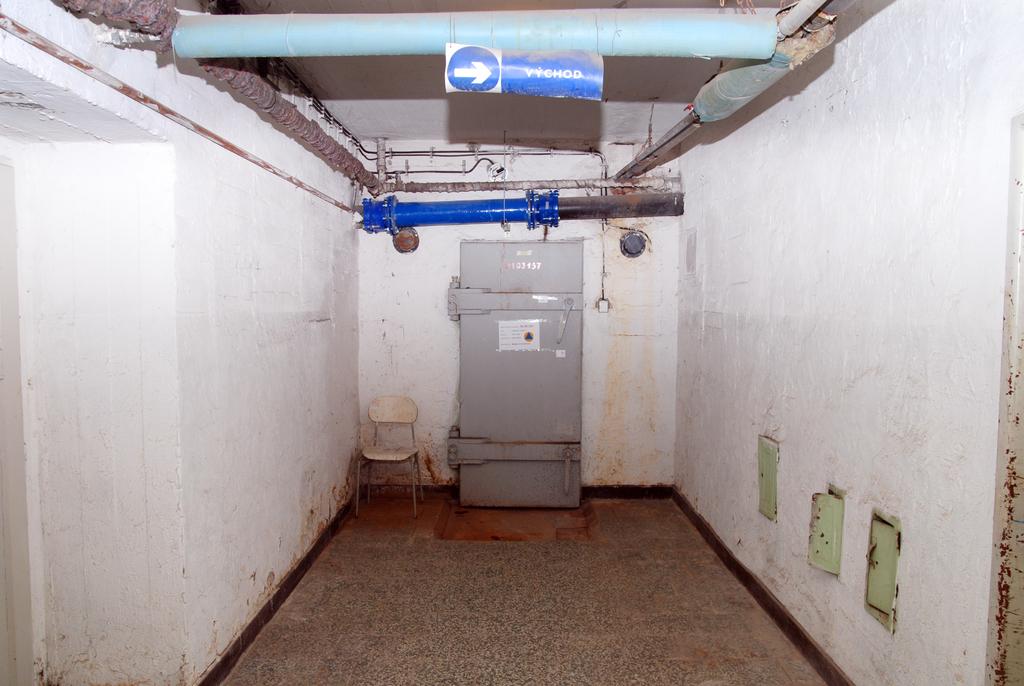What is to the right/?
Provide a short and direct response. Vychod. 